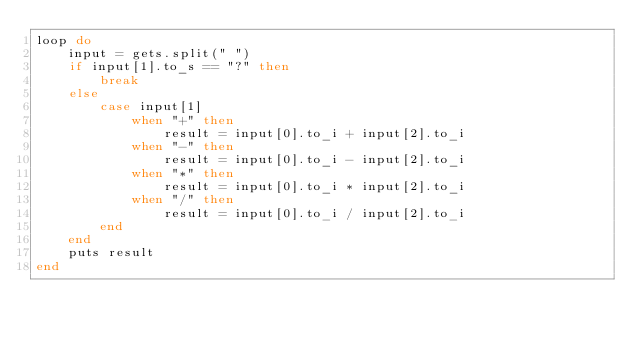<code> <loc_0><loc_0><loc_500><loc_500><_Ruby_>loop do
    input = gets.split(" ")
    if input[1].to_s == "?" then
        break
    else
        case input[1]
            when "+" then
                result = input[0].to_i + input[2].to_i
            when "-" then
                result = input[0].to_i - input[2].to_i
            when "*" then
                result = input[0].to_i * input[2].to_i
            when "/" then
                result = input[0].to_i / input[2].to_i
        end
    end
    puts result
end</code> 